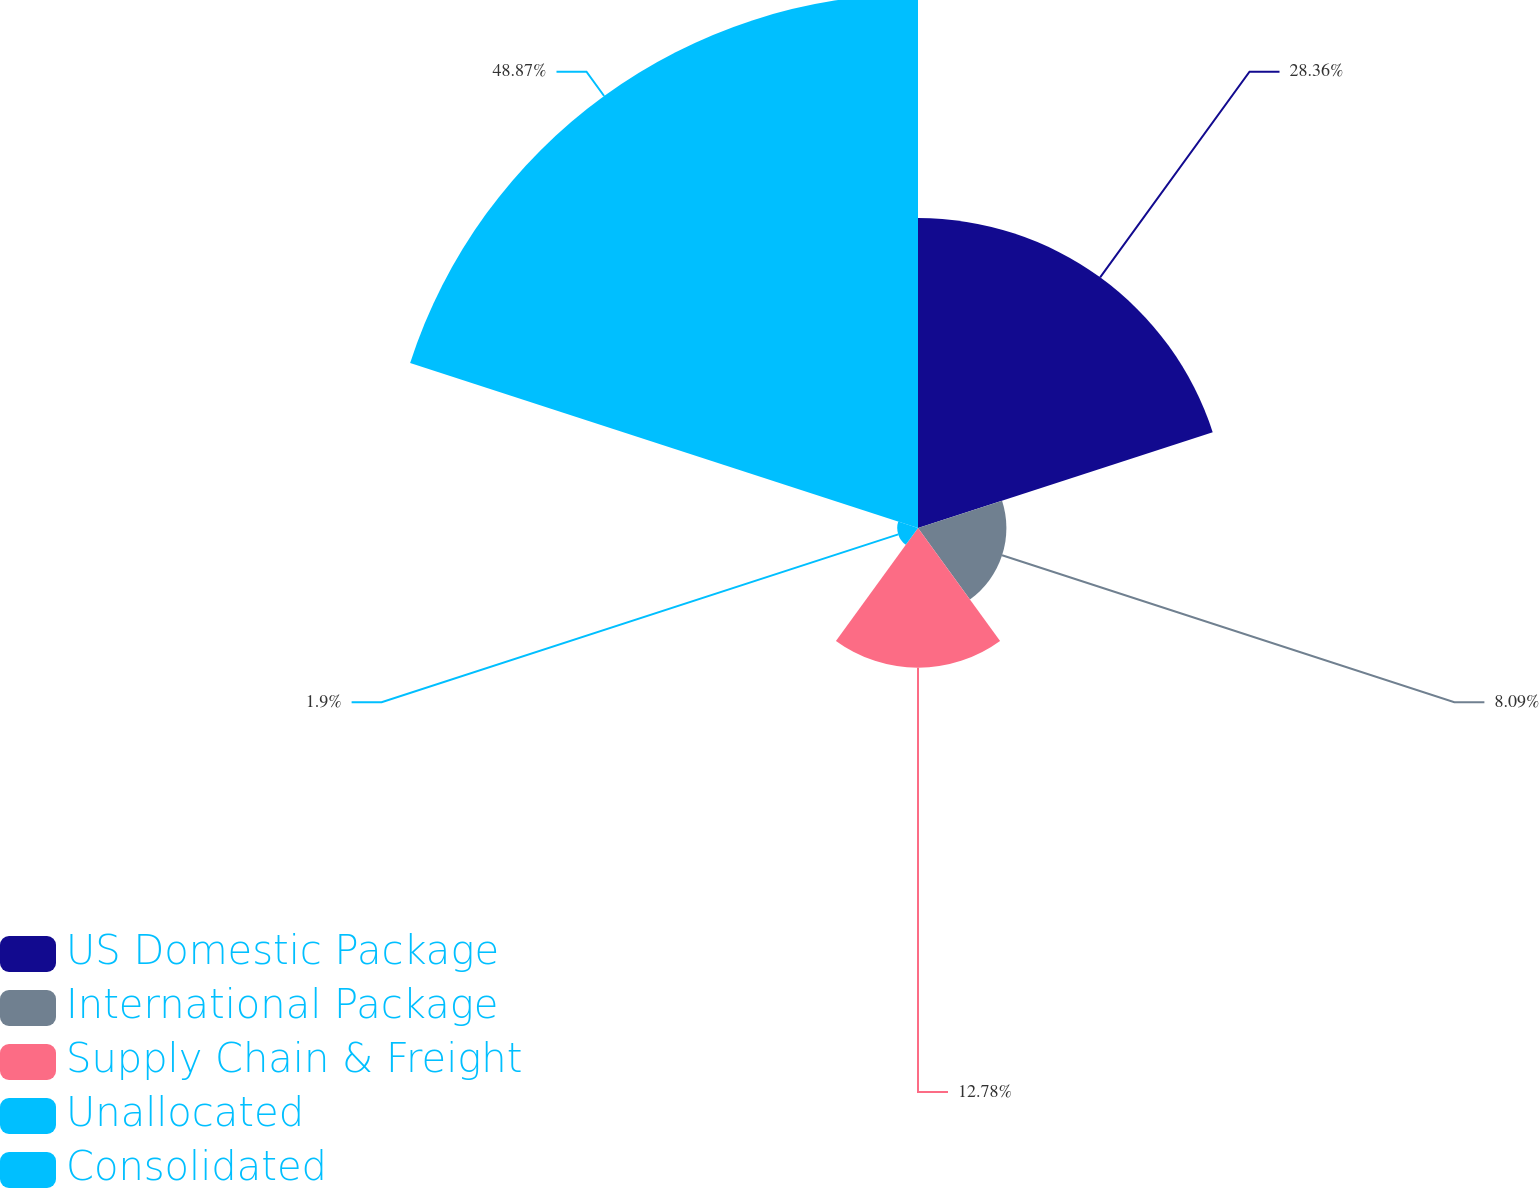Convert chart. <chart><loc_0><loc_0><loc_500><loc_500><pie_chart><fcel>US Domestic Package<fcel>International Package<fcel>Supply Chain & Freight<fcel>Unallocated<fcel>Consolidated<nl><fcel>28.36%<fcel>8.09%<fcel>12.78%<fcel>1.9%<fcel>48.87%<nl></chart> 